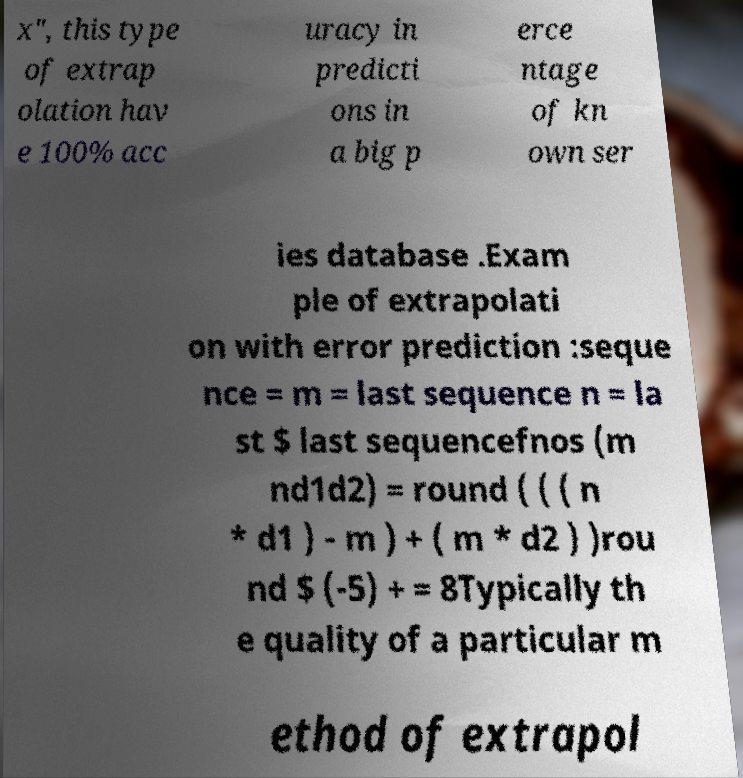There's text embedded in this image that I need extracted. Can you transcribe it verbatim? x", this type of extrap olation hav e 100% acc uracy in predicti ons in a big p erce ntage of kn own ser ies database .Exam ple of extrapolati on with error prediction :seque nce = m = last sequence n = la st $ last sequencefnos (m nd1d2) = round ( ( ( n * d1 ) - m ) + ( m * d2 ) )rou nd $ (-5) + = 8Typically th e quality of a particular m ethod of extrapol 